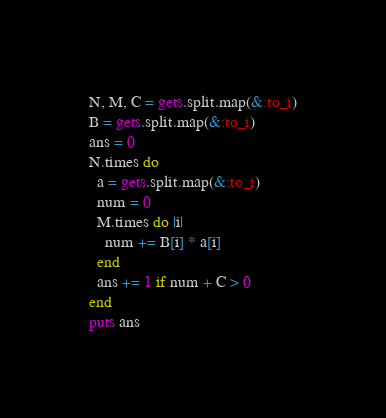Convert code to text. <code><loc_0><loc_0><loc_500><loc_500><_Ruby_>N, M, C = gets.split.map(&:to_i)
B = gets.split.map(&:to_i)
ans = 0
N.times do
  a = gets.split.map(&:to_i)
  num = 0
  M.times do |i|
    num += B[i] * a[i]
  end
  ans += 1 if num + C > 0
end
puts ans</code> 